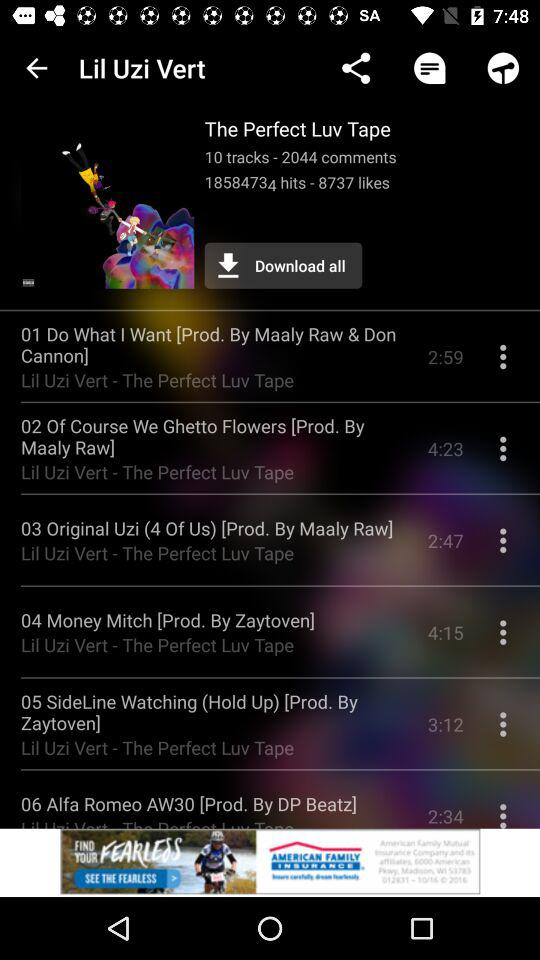How many tracks are on this album?
Answer the question using a single word or phrase. 10 